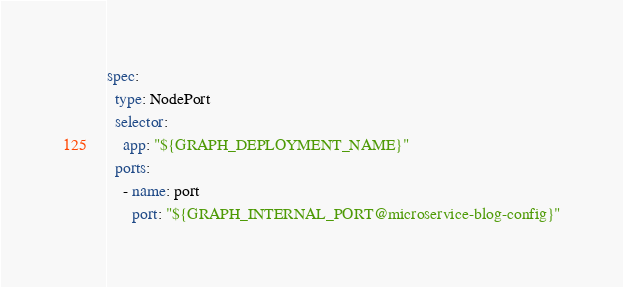<code> <loc_0><loc_0><loc_500><loc_500><_YAML_>spec:
  type: NodePort
  selector:
    app: "${GRAPH_DEPLOYMENT_NAME}"
  ports:
    - name: port
      port: "${GRAPH_INTERNAL_PORT@microservice-blog-config}"
</code> 